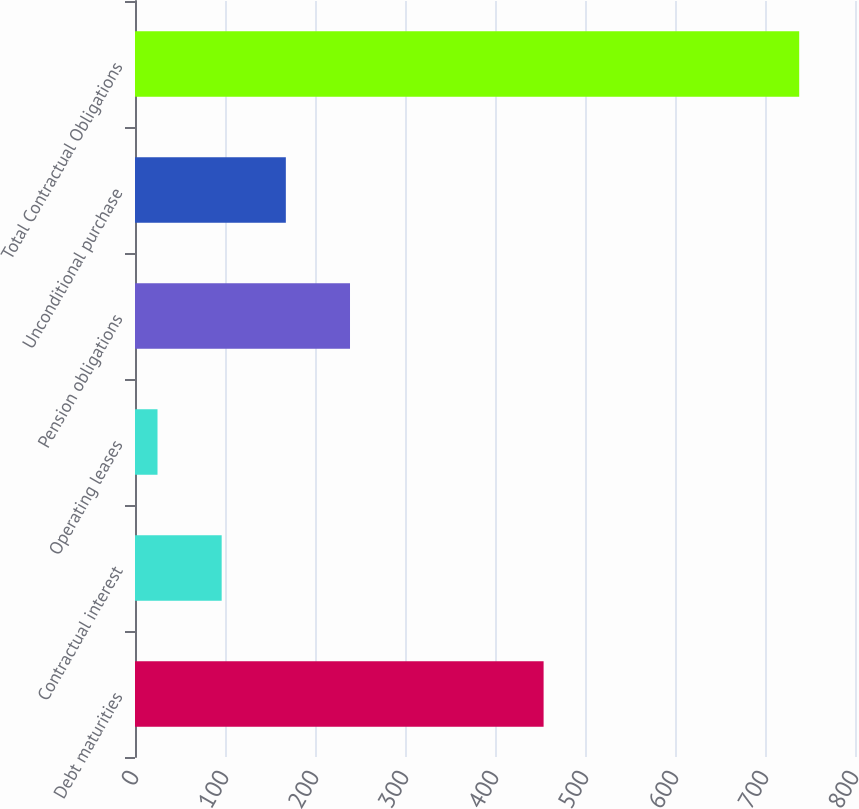Convert chart. <chart><loc_0><loc_0><loc_500><loc_500><bar_chart><fcel>Debt maturities<fcel>Contractual interest<fcel>Operating leases<fcel>Pension obligations<fcel>Unconditional purchase<fcel>Total Contractual Obligations<nl><fcel>454<fcel>96.3<fcel>25<fcel>238.9<fcel>167.6<fcel>738<nl></chart> 